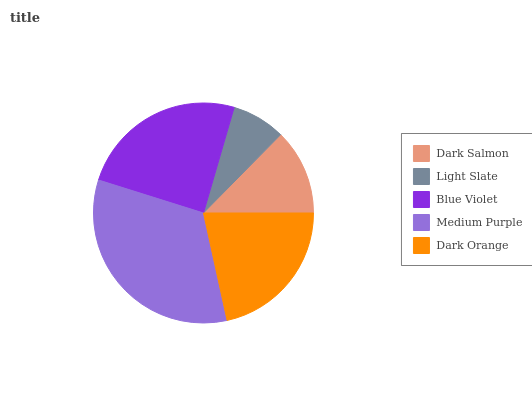Is Light Slate the minimum?
Answer yes or no. Yes. Is Medium Purple the maximum?
Answer yes or no. Yes. Is Blue Violet the minimum?
Answer yes or no. No. Is Blue Violet the maximum?
Answer yes or no. No. Is Blue Violet greater than Light Slate?
Answer yes or no. Yes. Is Light Slate less than Blue Violet?
Answer yes or no. Yes. Is Light Slate greater than Blue Violet?
Answer yes or no. No. Is Blue Violet less than Light Slate?
Answer yes or no. No. Is Dark Orange the high median?
Answer yes or no. Yes. Is Dark Orange the low median?
Answer yes or no. Yes. Is Blue Violet the high median?
Answer yes or no. No. Is Light Slate the low median?
Answer yes or no. No. 